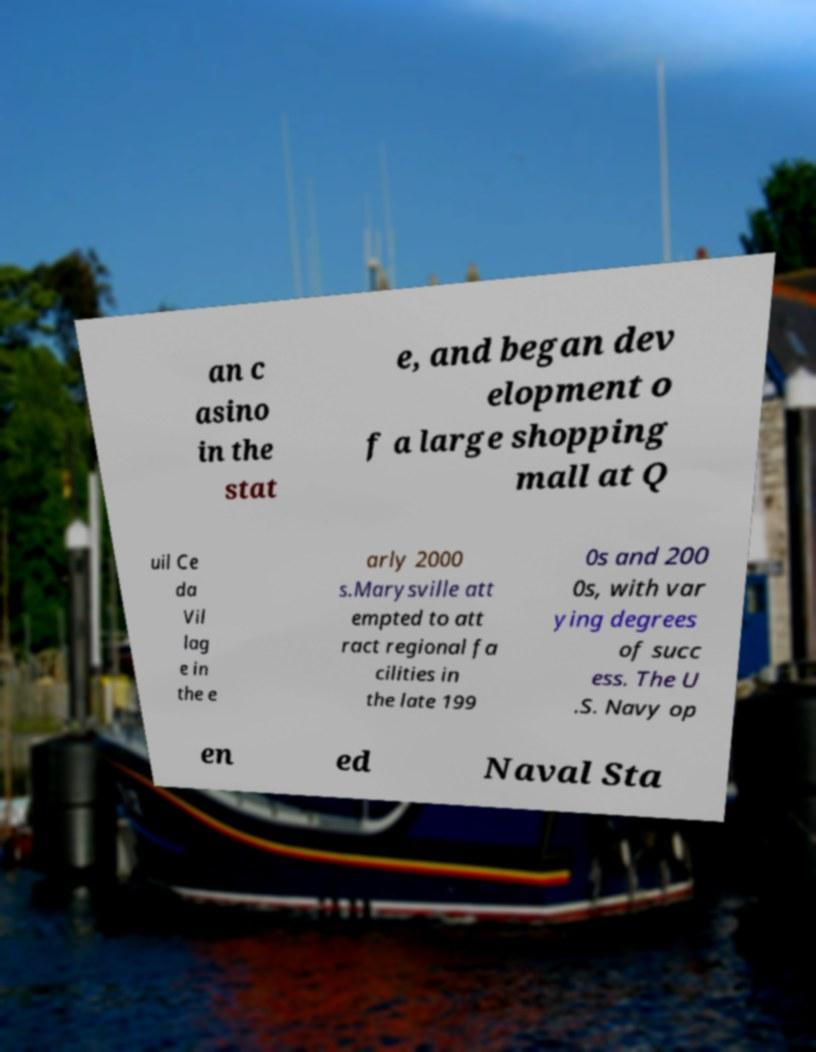What messages or text are displayed in this image? I need them in a readable, typed format. an c asino in the stat e, and began dev elopment o f a large shopping mall at Q uil Ce da Vil lag e in the e arly 2000 s.Marysville att empted to att ract regional fa cilities in the late 199 0s and 200 0s, with var ying degrees of succ ess. The U .S. Navy op en ed Naval Sta 